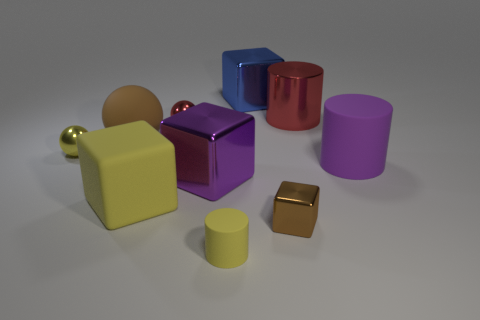Do the yellow cube and the yellow matte cylinder have the same size?
Offer a very short reply. No. There is a purple object right of the cylinder that is behind the purple cylinder; is there a shiny block behind it?
Your answer should be compact. Yes. There is a large brown object that is the same shape as the small red object; what material is it?
Ensure brevity in your answer.  Rubber. The big metal block behind the tiny red object is what color?
Ensure brevity in your answer.  Blue. The brown shiny thing has what size?
Keep it short and to the point. Small. Do the red metal sphere and the thing that is behind the red cylinder have the same size?
Ensure brevity in your answer.  No. There is a big shiny block that is left of the small yellow object to the right of the metal sphere in front of the rubber sphere; what is its color?
Your answer should be very brief. Purple. Do the cube that is behind the red sphere and the purple cylinder have the same material?
Offer a very short reply. No. How many other objects are the same material as the large purple cylinder?
Make the answer very short. 3. There is a red cylinder that is the same size as the purple cylinder; what is it made of?
Offer a very short reply. Metal. 